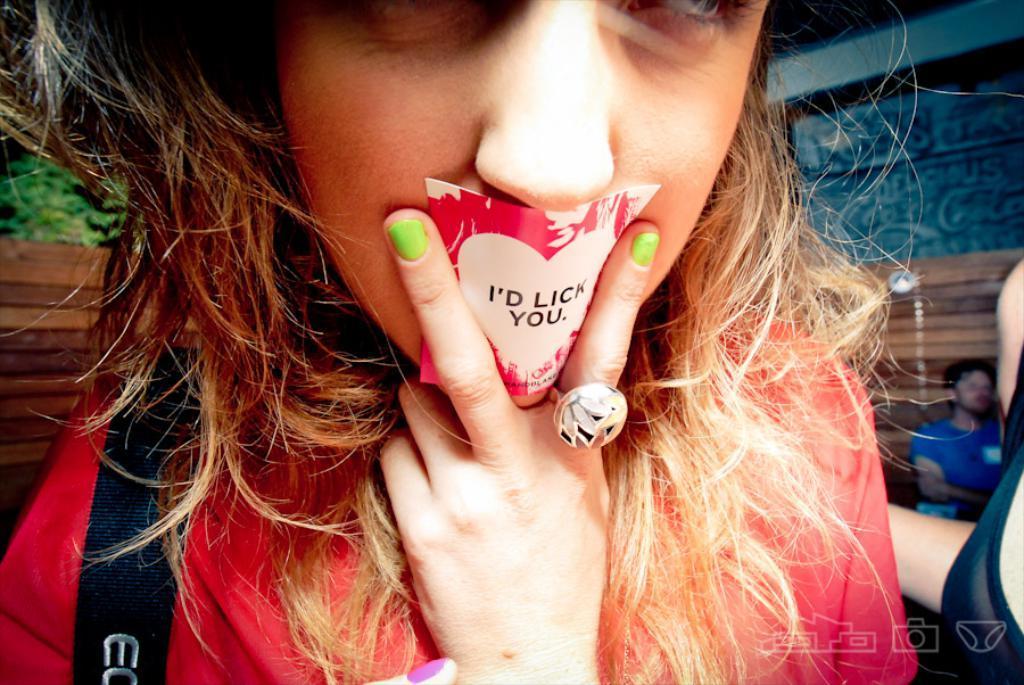Could you give a brief overview of what you see in this image? This woman wore a ring and holding a sticker. Background it is blurry, we can see tree and person. 